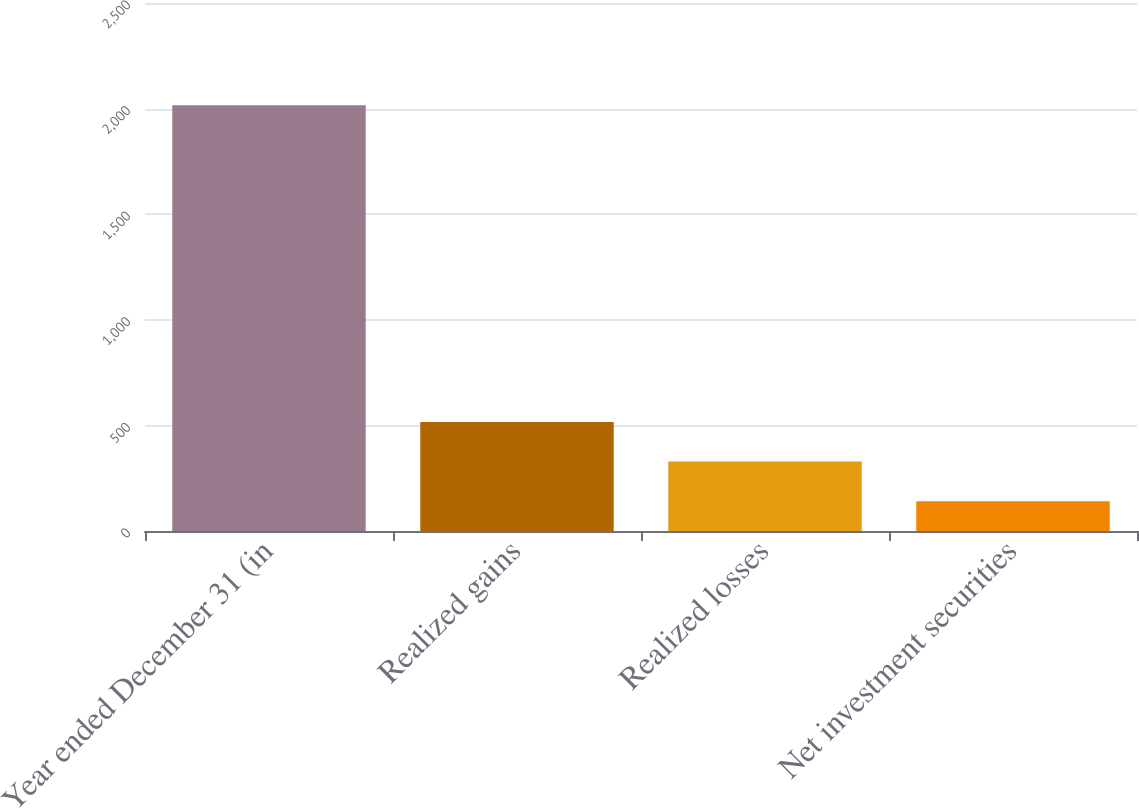<chart> <loc_0><loc_0><loc_500><loc_500><bar_chart><fcel>Year ended December 31 (in<fcel>Realized gains<fcel>Realized losses<fcel>Net investment securities<nl><fcel>2016<fcel>516<fcel>328.5<fcel>141<nl></chart> 